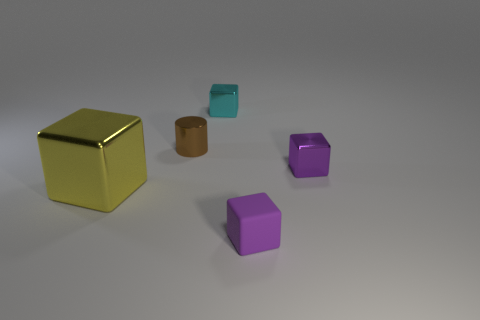What is the color of the metal thing that is in front of the metallic cylinder and on the right side of the yellow metal object?
Ensure brevity in your answer.  Purple. There is a tiny brown shiny thing; what number of cylinders are right of it?
Offer a very short reply. 0. What number of objects are either red metal things or small shiny cubes that are left of the purple metal thing?
Your response must be concise. 1. Is there a matte thing that is behind the thing on the left side of the brown metal object?
Your response must be concise. No. What is the color of the tiny metallic block that is to the left of the purple matte thing?
Provide a short and direct response. Cyan. Are there an equal number of brown metallic cylinders that are in front of the large metallic object and yellow objects?
Give a very brief answer. No. The thing that is in front of the purple metal cube and behind the small matte thing has what shape?
Provide a short and direct response. Cube. What color is the large metal object that is the same shape as the tiny purple matte object?
Provide a succinct answer. Yellow. Is there any other thing of the same color as the tiny metal cylinder?
Your response must be concise. No. There is a small shiny object that is to the right of the purple thing that is on the left side of the small metallic object that is in front of the brown metal cylinder; what is its shape?
Your answer should be very brief. Cube. 